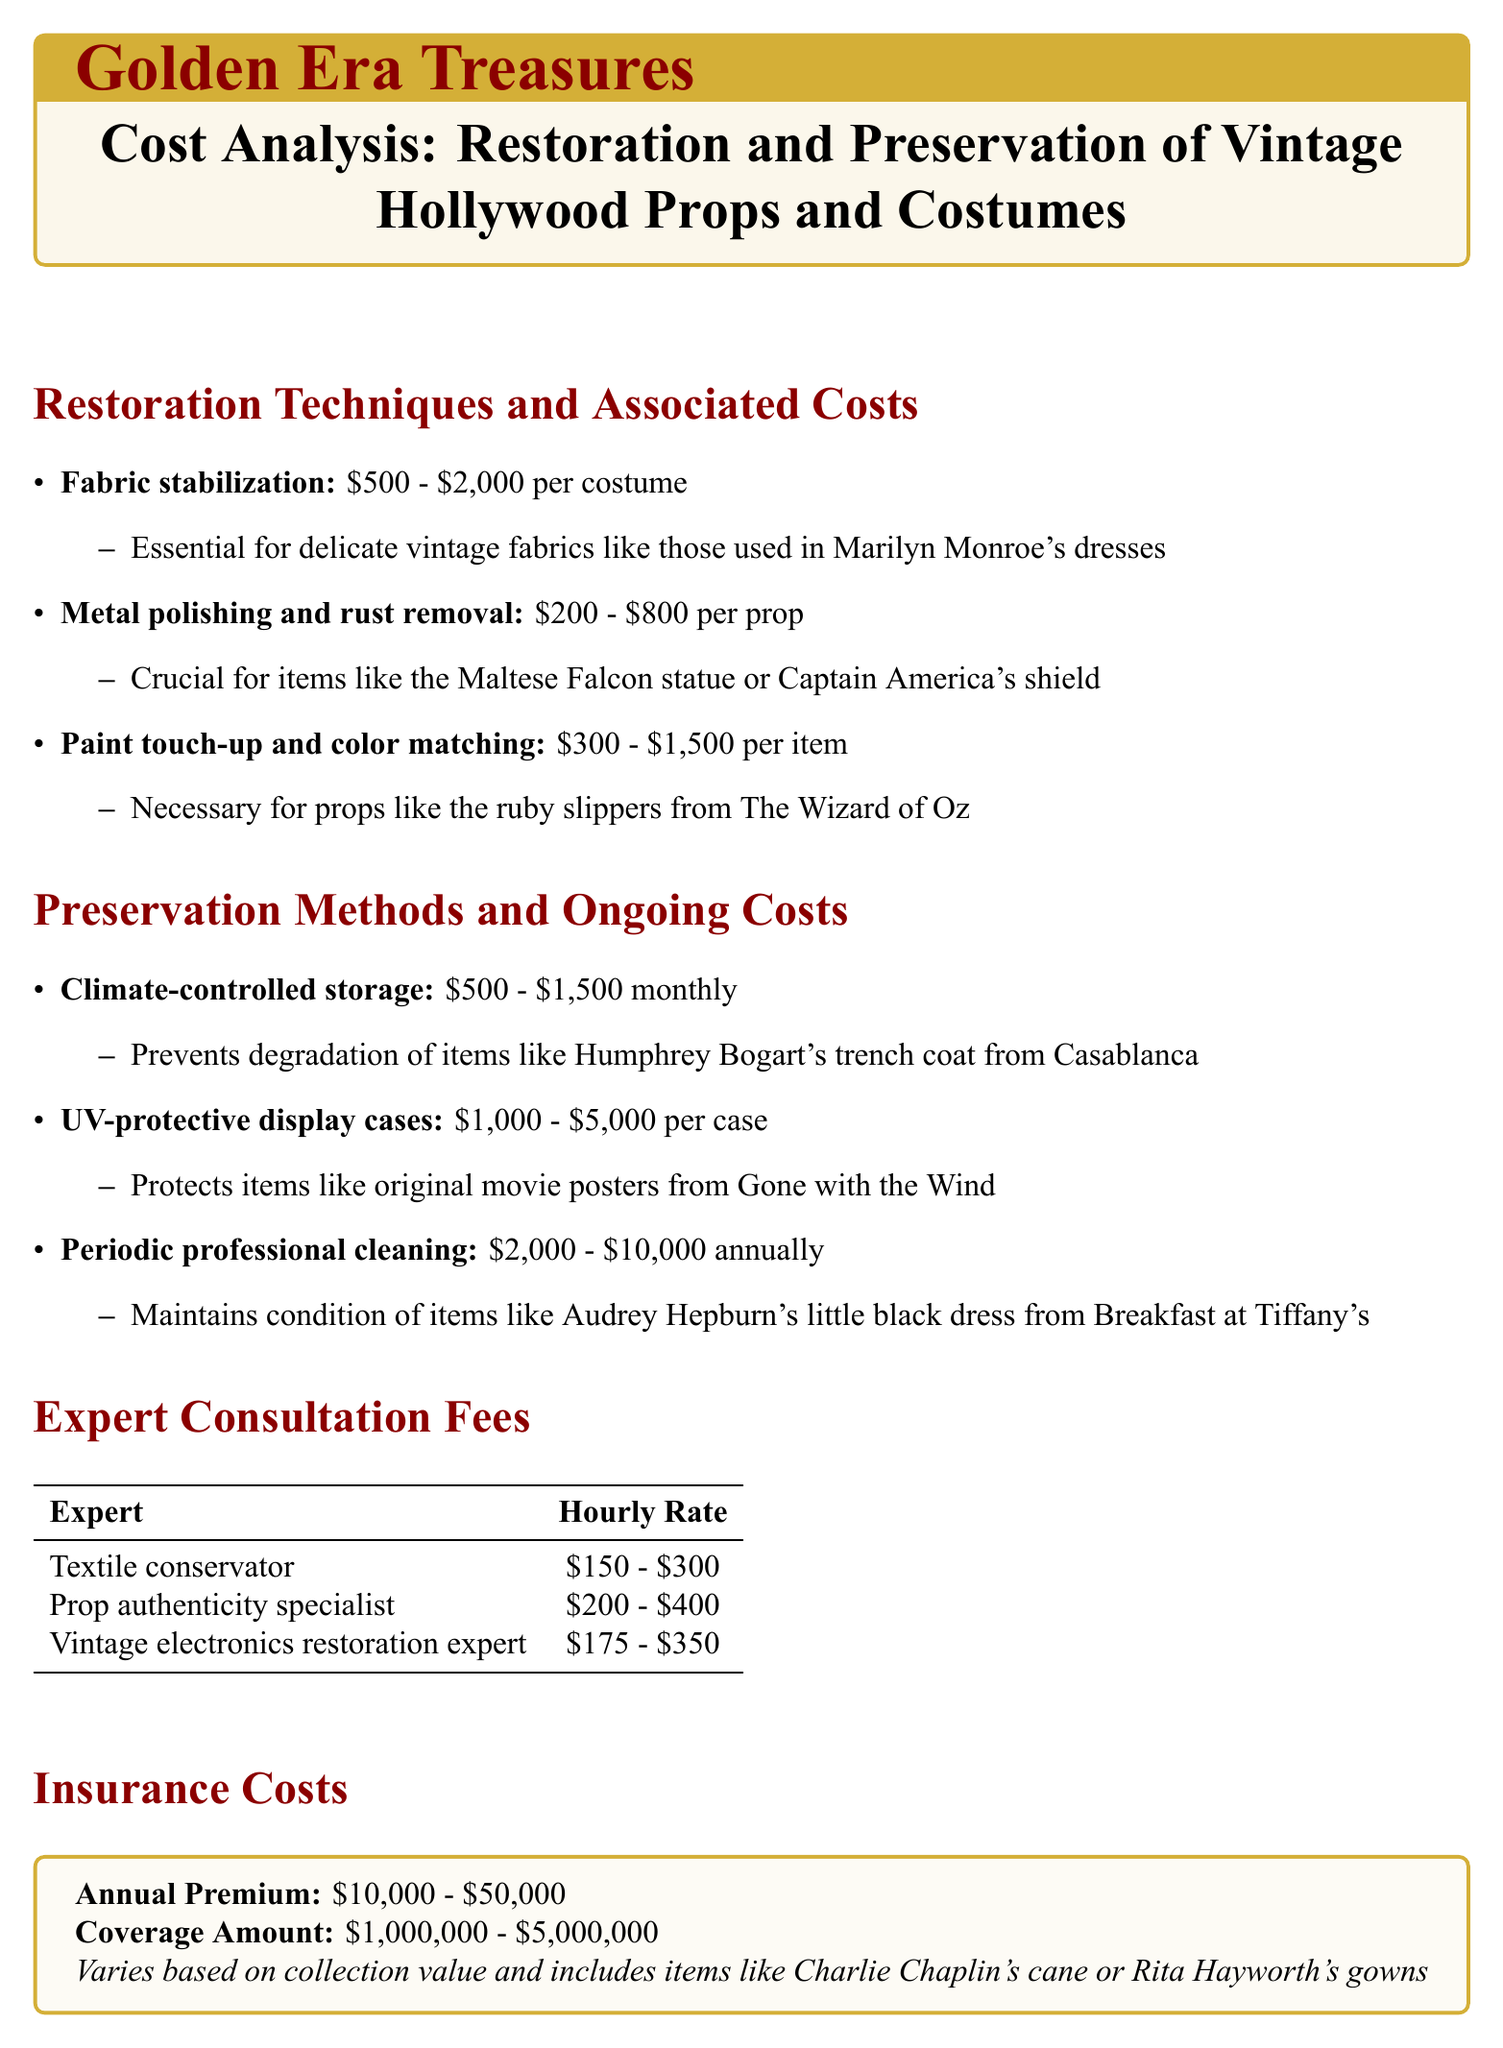what is the average cost for fabric stabilization? The average cost for fabric stabilization is mentioned in the document as ranging from $500 to $2,000 per costume.
Answer: $500 - $2,000 per costume what is the monthly cost of climate-controlled storage? The document states that the monthly cost for climate-controlled storage is between $500 and $1,500.
Answer: $500 - $1,500 what type of expert charges $200 to $400 per hour? The document specifies the prop authenticity specialist charges $200 to $400 per hour.
Answer: Prop authenticity specialist what is the range of annual premiums for insurance costs? The document indicates that the annual premiums for insurance costs range from $10,000 to $50,000.
Answer: $10,000 - $50,000 which restoration technique is essential for delicate vintage fabrics? The document categorizes fabric stabilization as essential for delicate vintage fabrics.
Answer: Fabric stabilization how much does periodic professional cleaning cost annually? According to the document, periodic professional cleaning costs between $2,000 and $10,000 annually.
Answer: $2,000 - $10,000 what item requires metal polishing and rust removal? The document lists items like the Maltese Falcon statue as requiring metal polishing and rust removal.
Answer: Maltese Falcon statue what is the coverage amount for insurance costs? The insurance section of the document indicates coverage amounts between $1,000,000 and $5,000,000.
Answer: $1,000,000 - $5,000,000 what is the hourly rate range for a textile conservator? The document specifies that the hourly rate for a textile conservator ranges from $150 to $300.
Answer: $150 - $300 